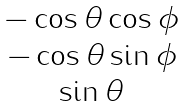Convert formula to latex. <formula><loc_0><loc_0><loc_500><loc_500>\begin{matrix} - \cos { \theta } \cos { \phi } \\ - \cos { \theta } \sin { \phi } \\ \sin { \theta } \end{matrix}</formula> 